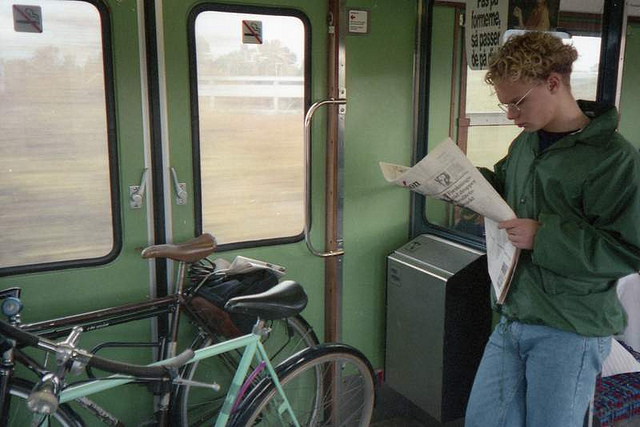Read all the text in this image. passer 